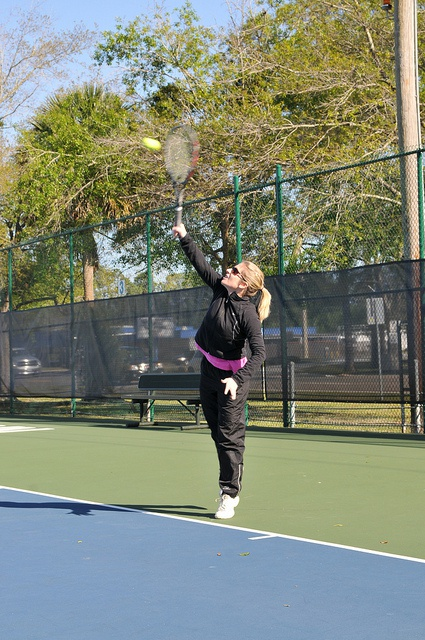Describe the objects in this image and their specific colors. I can see people in lightblue, black, gray, ivory, and tan tones, bench in lightblue, black, gray, blue, and darkgreen tones, tennis racket in lightblue, darkgray, tan, and gray tones, truck in lightblue, gray, darkblue, darkgray, and ivory tones, and car in lightblue, gray, purple, and black tones in this image. 